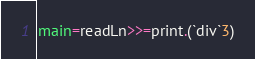<code> <loc_0><loc_0><loc_500><loc_500><_Haskell_>main=readLn>>=print.(`div`3)</code> 